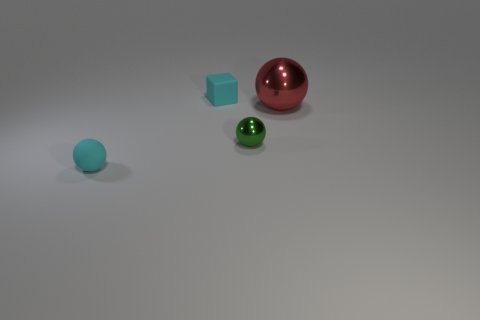Subtract all blue spheres. Subtract all purple cylinders. How many spheres are left? 3 Add 3 tiny things. How many objects exist? 7 Subtract all cubes. How many objects are left? 3 Add 4 matte blocks. How many matte blocks are left? 5 Add 4 tiny blue matte blocks. How many tiny blue matte blocks exist? 4 Subtract 0 purple cylinders. How many objects are left? 4 Subtract all big red shiny spheres. Subtract all big metallic balls. How many objects are left? 2 